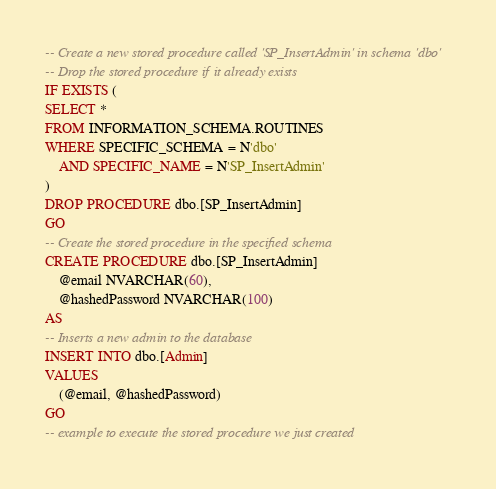<code> <loc_0><loc_0><loc_500><loc_500><_SQL_>-- Create a new stored procedure called 'SP_InsertAdmin' in schema 'dbo'
-- Drop the stored procedure if it already exists
IF EXISTS (
SELECT *
FROM INFORMATION_SCHEMA.ROUTINES
WHERE SPECIFIC_SCHEMA = N'dbo'
    AND SPECIFIC_NAME = N'SP_InsertAdmin'
)
DROP PROCEDURE dbo.[SP_InsertAdmin]
GO
-- Create the stored procedure in the specified schema
CREATE PROCEDURE dbo.[SP_InsertAdmin]
    @email NVARCHAR(60),
    @hashedPassword NVARCHAR(100)
AS
-- Inserts a new admin to the database
INSERT INTO dbo.[Admin]
VALUES
    (@email, @hashedPassword)
GO
-- example to execute the stored procedure we just created
</code> 